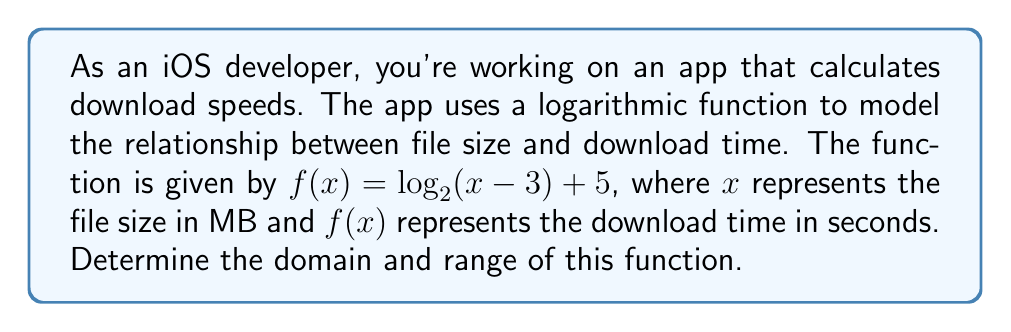Teach me how to tackle this problem. Let's approach this step-by-step:

1. Domain:
   The domain of a logarithmic function is all real numbers for which the argument (the expression inside the logarithm) is positive.

   For $f(x) = \log_2(x - 3) + 5$, we need:
   $x - 3 > 0$
   $x > 3$

   Since file size can't be negative or zero, this restriction makes sense in the context of the problem.

2. Range:
   To find the range, let's consider the properties of logarithms:
   
   - As $x$ approaches 3 from the right, $x - 3$ approaches 0, and $\log_2(x - 3)$ approaches negative infinity.
   - As $x$ increases, $\log_2(x - 3)$ increases but does so very slowly.

   The function $f(x)$ is $\log_2(x - 3)$ shifted up by 5 units.

   Therefore, as $x$ approaches 3 from the right, $f(x)$ approaches negative infinity.
   As $x$ increases indefinitely, $f(x)$ increases without bound.

   So, the range of $f(x)$ is all real numbers.

In the context of the app, this means:
- The function is defined for all file sizes greater than 3 MB.
- The download time can be any positive real number, approaching but never reaching 5 seconds as the file size gets very close to 3 MB, and increasing without limit for larger file sizes.
Answer: Domain: $(3, \infty)$; Range: $(-\infty, \infty)$ 